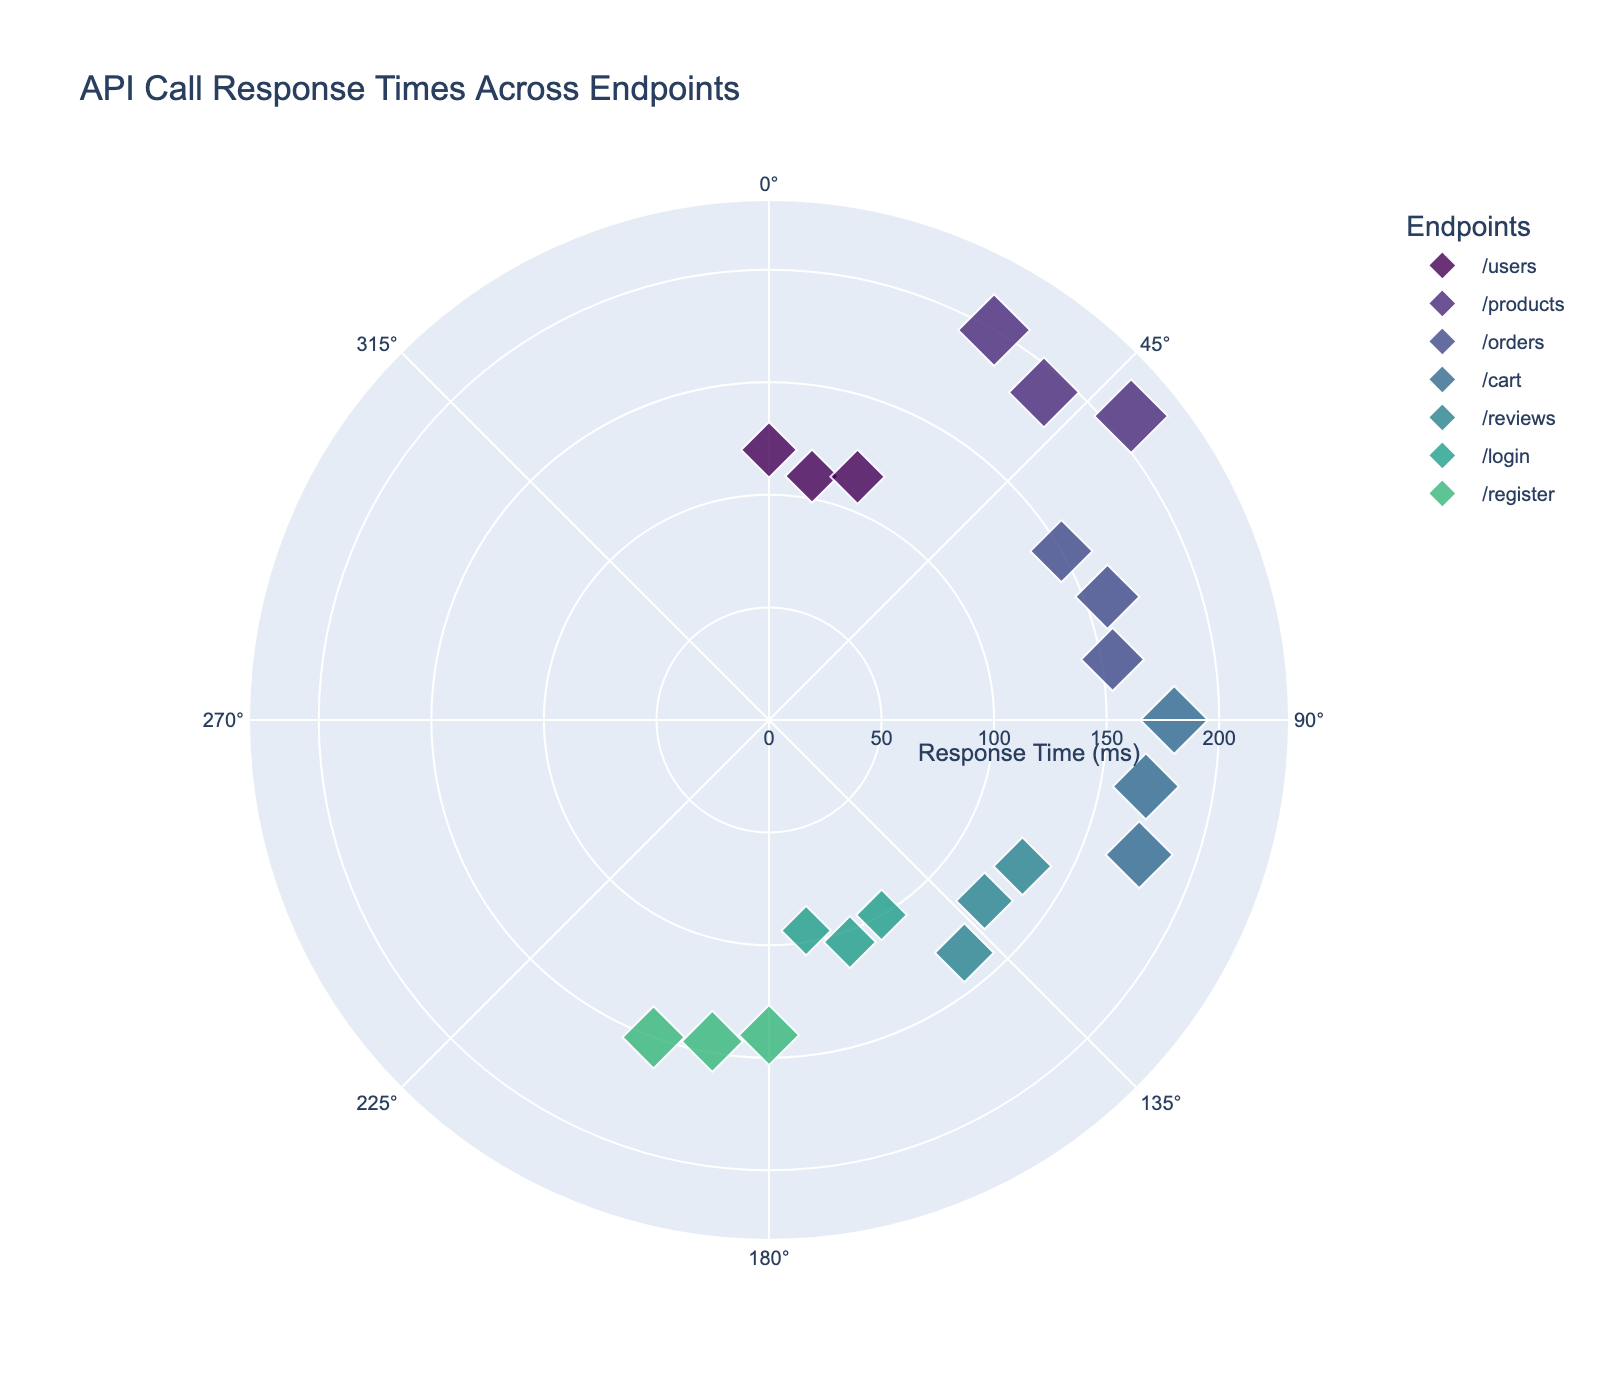What is the title of the chart? The title of the chart is displayed at the top and it summarizes the figure content. In this case, the title is "API Call Response Times Across Endpoints".
Answer: API Call Response Times Across Endpoints Which endpoint has the highest average response time? To determine the highest average response time, look at the response times for each endpoint and calculate their averages. The "products" endpoint has response times of 200, 190, and 210 ms, thus its average is (200+190+210)/3 = 200 ms, which is higher than the averages of the other endpoints.
Answer: products What is the range of response times for the "orders" endpoint? The response times for the "orders" endpoint are 150 ms, 160 ms, and 155 ms. The range is calculated as the difference between the maximum and minimum values, which is 160 ms - 150 ms = 10 ms.
Answer: 10 ms Which endpoint shows the most variability in response times? Variability can be assessed by looking at the spread of the response times for each endpoint. The "products" endpoint has response times of 200, 190, and 210 ms, and this spread (max - min = 210 - 190 = 20 ms) is the widest, indicating the highest variability.
Answer: products How does the response time for the "login" endpoint compare to the "register" endpoint? Compare the response times of these endpoints directly. The "login" endpoint has response times of 100 ms, 105 ms, and 95 ms, while the "register" endpoint has 140 ms, 145 ms, and 150 ms. The response times for "register" are consistently higher than those for "login".
Answer: register response times are higher How many data points are there in the chart for each endpoint? Count the number of occurrences for each endpoint in the data. Each endpoint ("users", "products", "orders", "cart", "reviews", "login", "register") has exactly 3 data points each.
Answer: 3 data points What's the median response time for the "reviews" endpoint? To find the median, arrange the response times in numerical order and find the middle value. For "reviews", the response times are 125, 130, and 135 ms. The median is the middle value, which is 130 ms.
Answer: 130 ms Which endpoint has the smallest response time, and what is it? Look for the smallest value in the "ResponseTime" column. The smallest response time is 95 ms, which corresponds to the "login" endpoint.
Answer: login, 95 ms What can we infer about the performance of the "cart" endpoint compared to others? Compare the response times of the "cart" endpoint with other endpoints. The "cart" endpoint has response times of 180 ms, 170 ms, and 175 ms, which are higher than "login" and "reviews", but lower than "products". Thus, it performs better than "products" but worse than "login" and "reviews".
Answer: Better than products, worse than login and reviews Based on the chart, which two endpoints have the closest response times? Identify pairs of endpoints that have similar response times. The "users" endpoint has response times around 110-120 ms, which is close to the "reviews" endpoint with response times around 125-135 ms.
Answer: users and reviews 